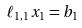<formula> <loc_0><loc_0><loc_500><loc_500>\ell _ { 1 , 1 } x _ { 1 } = b _ { 1 }</formula> 